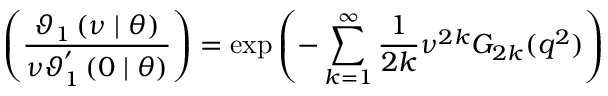<formula> <loc_0><loc_0><loc_500><loc_500>\left ( \frac { \mathcal { \vartheta } _ { 1 } \left ( \nu | \theta \right ) } { \nu \mathcal { \vartheta } _ { 1 } ^ { ^ { \prime } } \left ( 0 | \theta \right ) } \right ) = \exp \left ( - \sum _ { k = 1 } ^ { \infty } \frac { 1 } { 2 k } \nu ^ { 2 k } G _ { 2 k } ( q ^ { 2 } ) \right )</formula> 